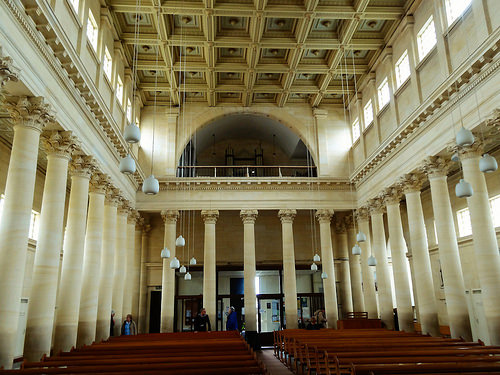<image>
Is there a pew behind the pillar? No. The pew is not behind the pillar. From this viewpoint, the pew appears to be positioned elsewhere in the scene. 